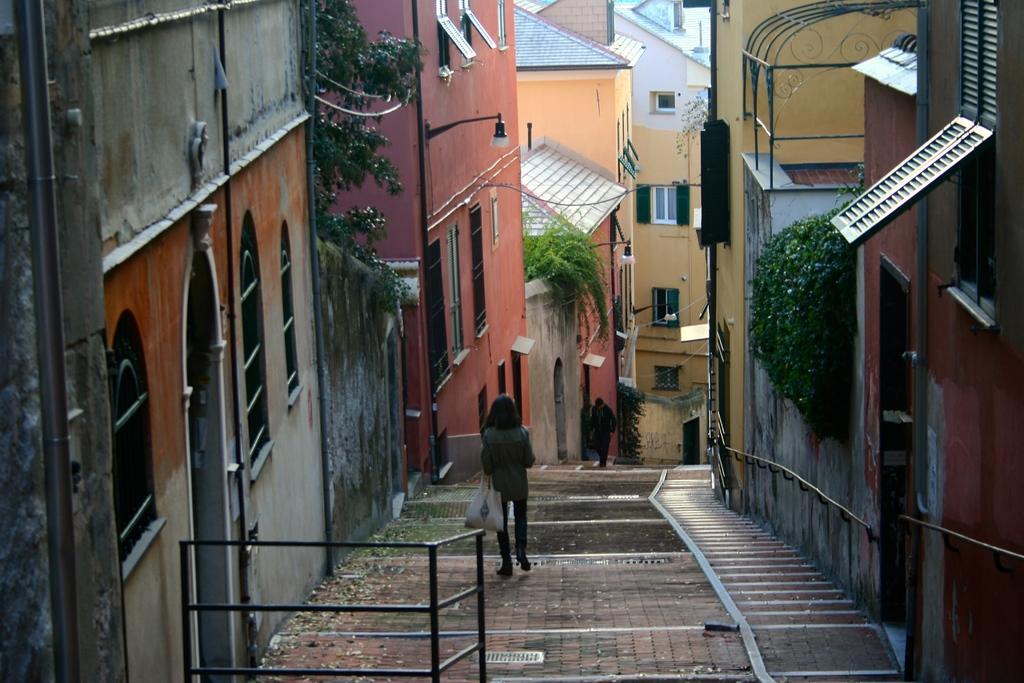How would you summarize this image in a sentence or two? In the center of the image we can see two people walking. In the background there are buildings and trees. We can see lights. 